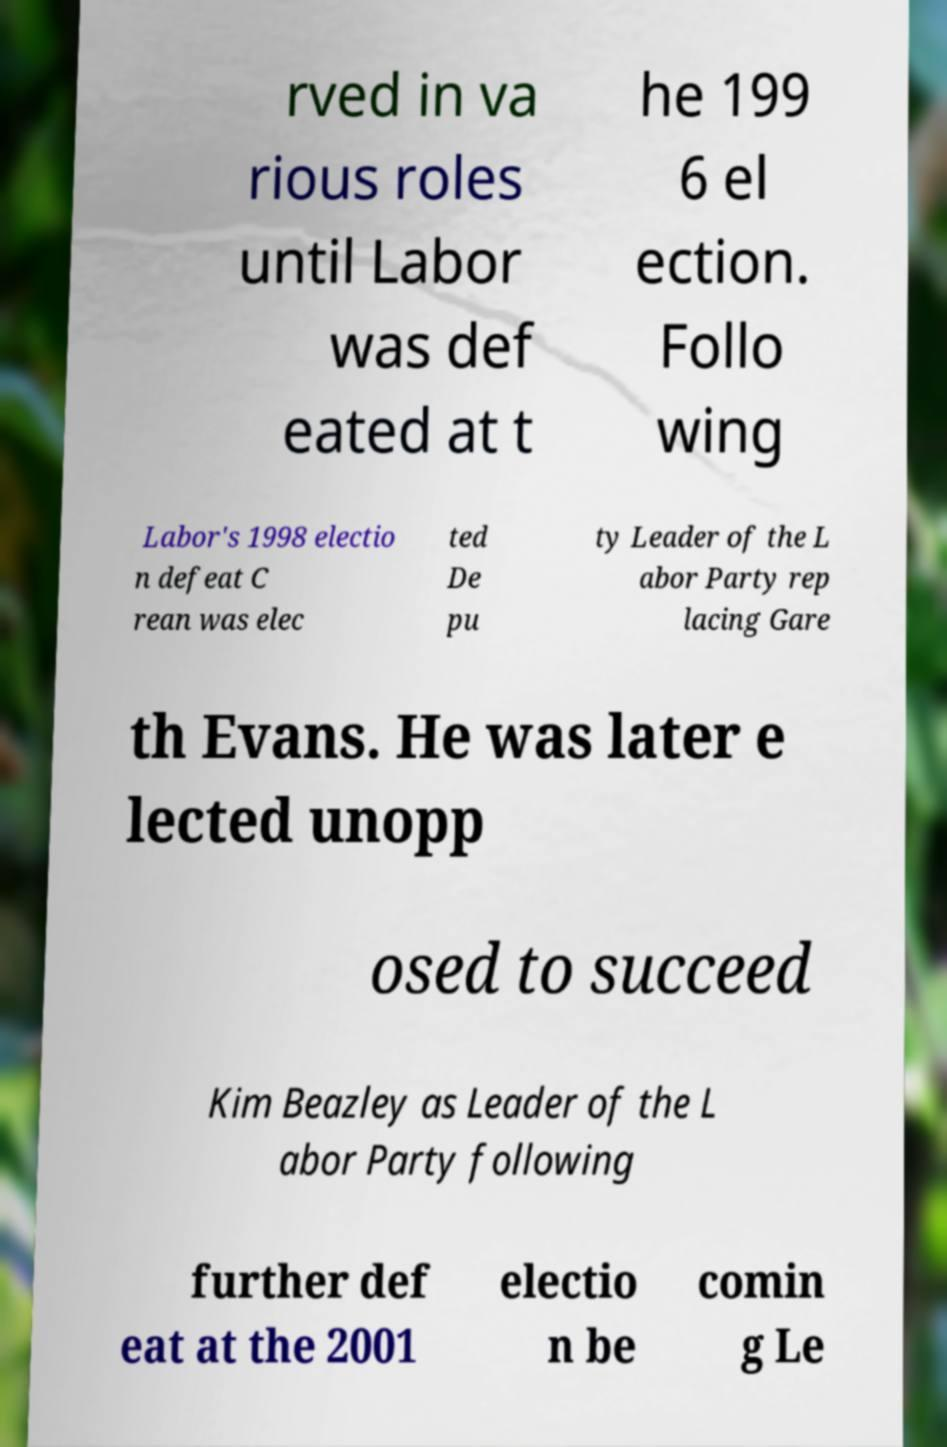I need the written content from this picture converted into text. Can you do that? rved in va rious roles until Labor was def eated at t he 199 6 el ection. Follo wing Labor's 1998 electio n defeat C rean was elec ted De pu ty Leader of the L abor Party rep lacing Gare th Evans. He was later e lected unopp osed to succeed Kim Beazley as Leader of the L abor Party following further def eat at the 2001 electio n be comin g Le 